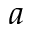<formula> <loc_0><loc_0><loc_500><loc_500>a</formula> 